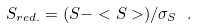Convert formula to latex. <formula><loc_0><loc_0><loc_500><loc_500>S _ { r e d . } = ( S - < S > ) / \sigma _ { S } \ .</formula> 